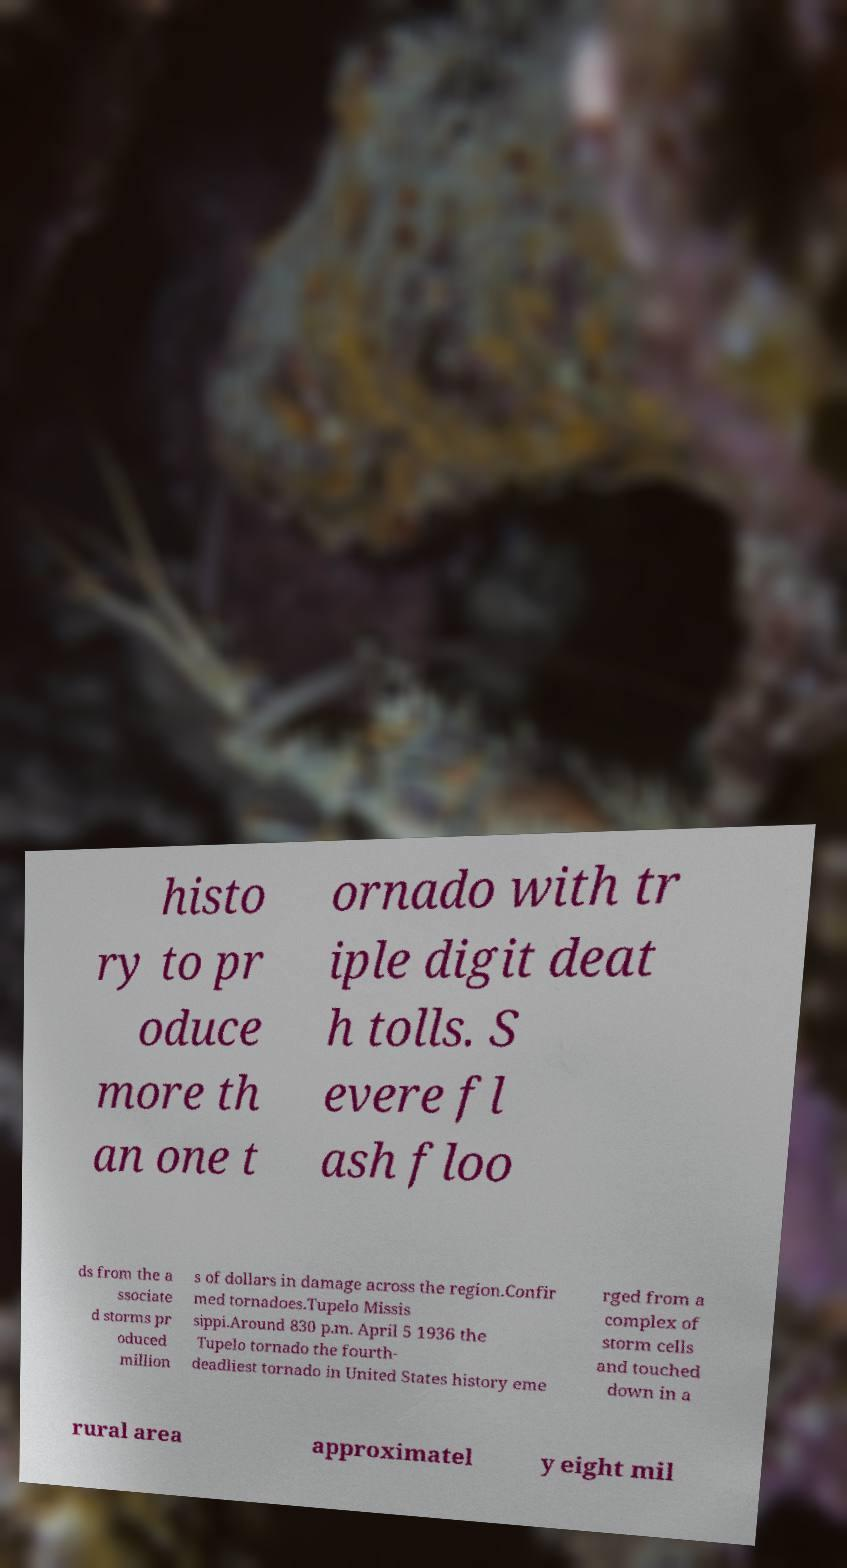Can you read and provide the text displayed in the image?This photo seems to have some interesting text. Can you extract and type it out for me? histo ry to pr oduce more th an one t ornado with tr iple digit deat h tolls. S evere fl ash floo ds from the a ssociate d storms pr oduced million s of dollars in damage across the region.Confir med tornadoes.Tupelo Missis sippi.Around 830 p.m. April 5 1936 the Tupelo tornado the fourth- deadliest tornado in United States history eme rged from a complex of storm cells and touched down in a rural area approximatel y eight mil 